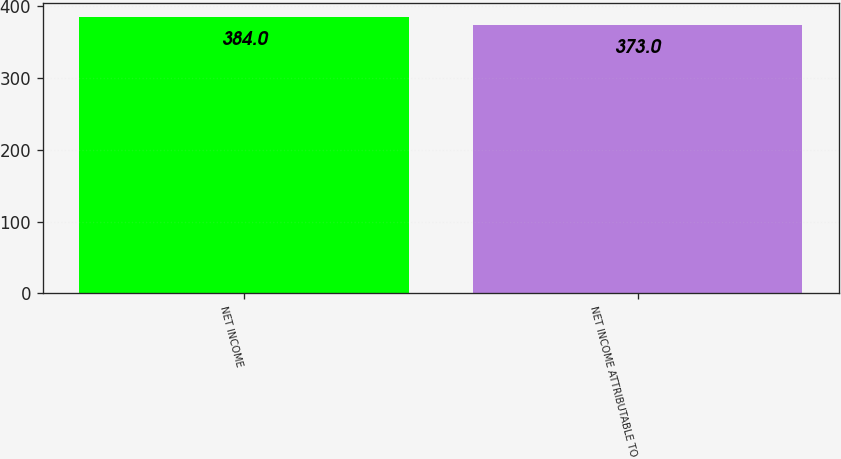Convert chart to OTSL. <chart><loc_0><loc_0><loc_500><loc_500><bar_chart><fcel>NET INCOME<fcel>NET INCOME ATTRIBUTABLE TO<nl><fcel>384<fcel>373<nl></chart> 